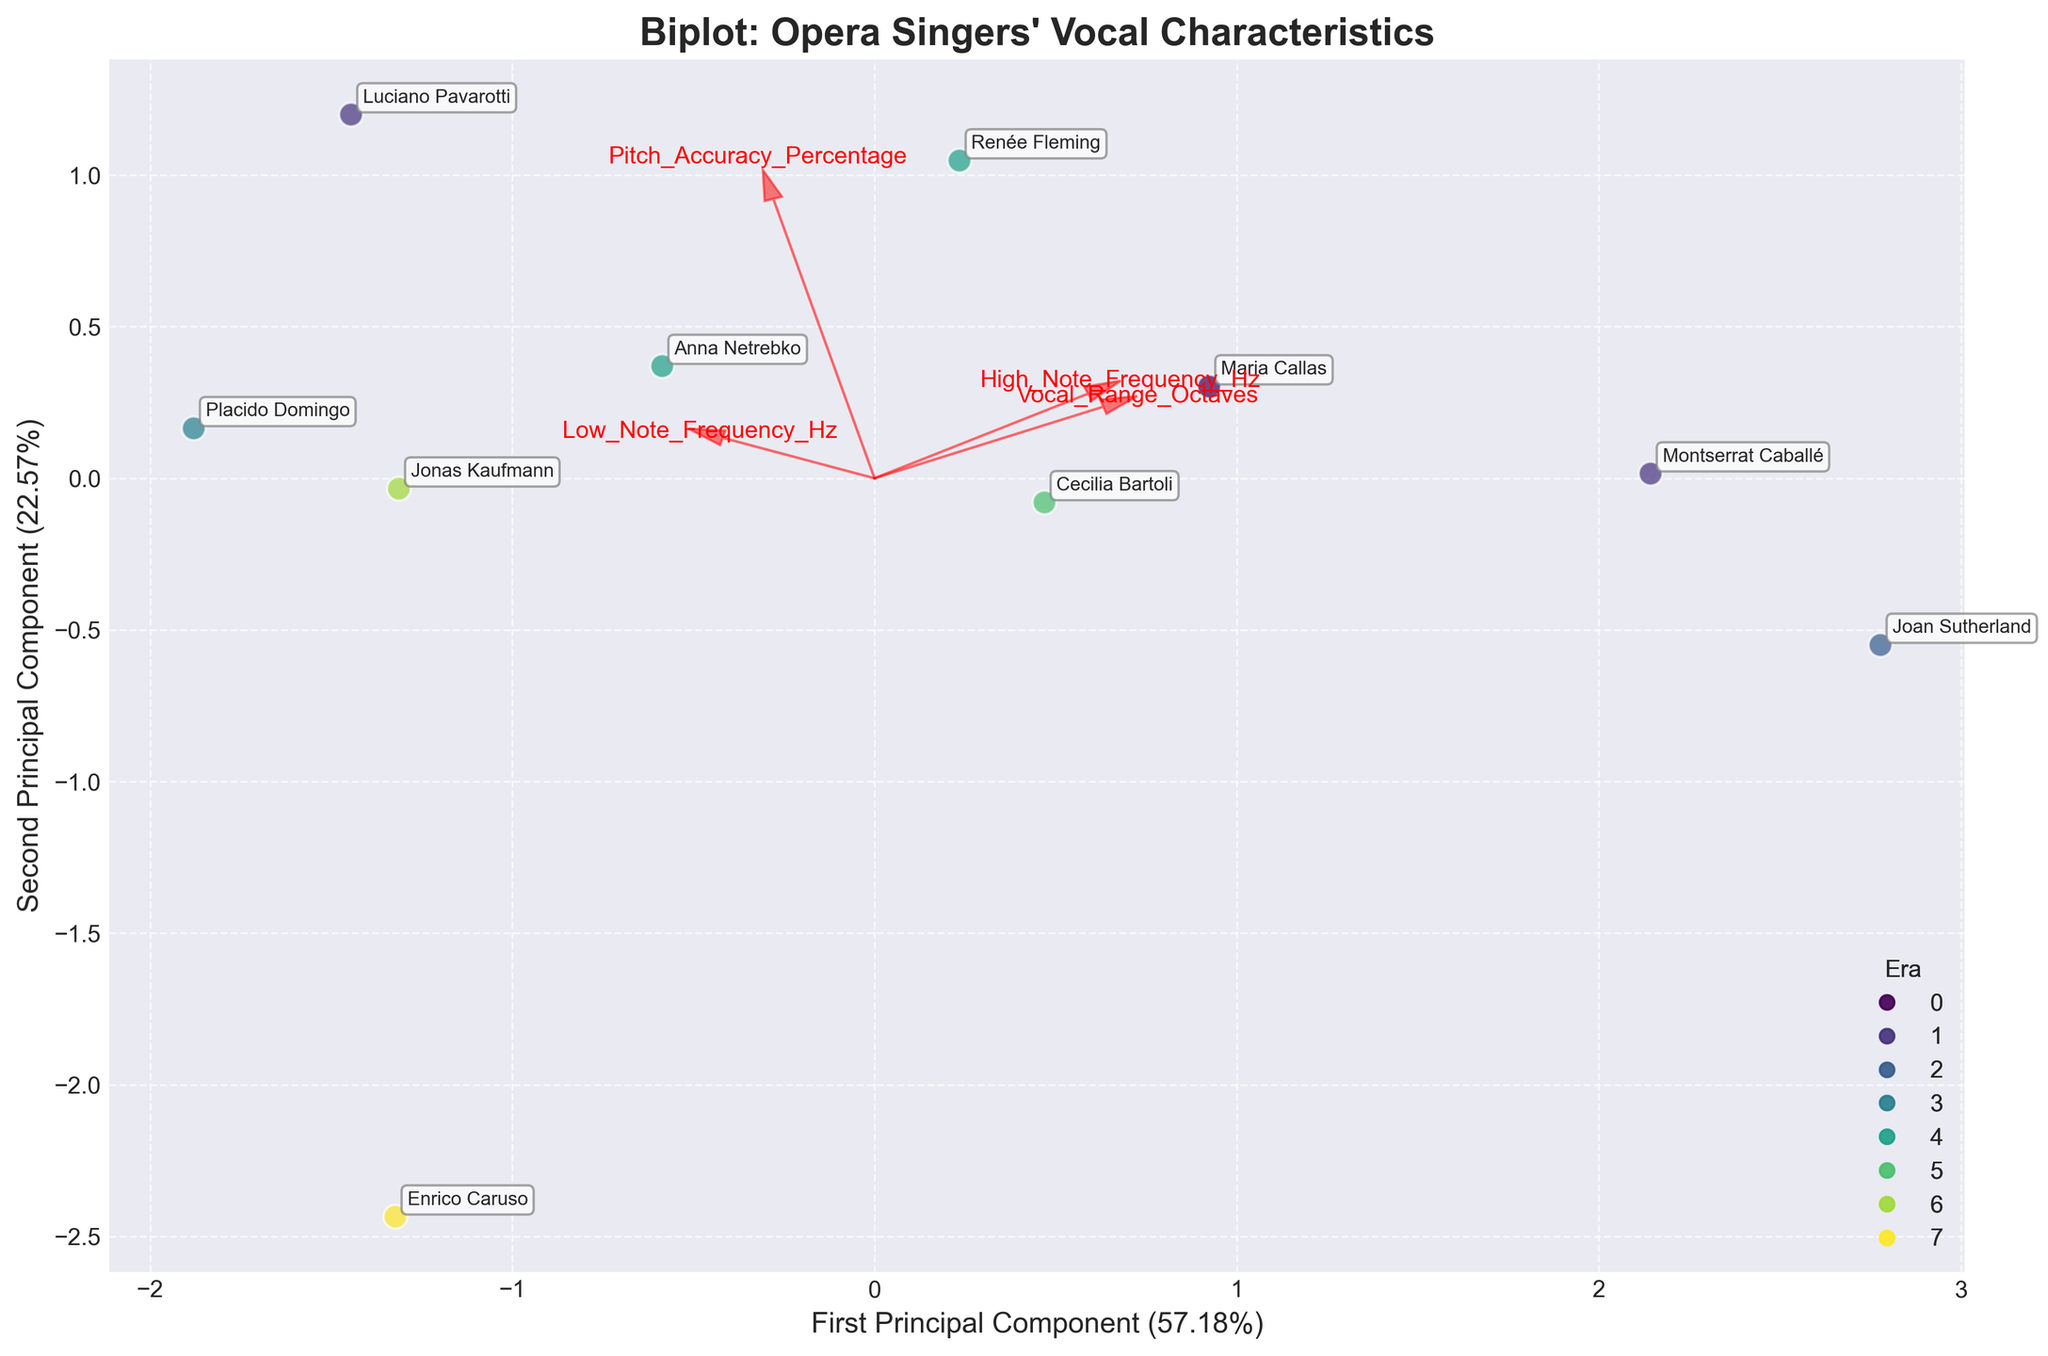What is the title of the plot? The title of the plot is displayed at the top of the figure and reads "Biplot: Opera Singers' Vocal Characteristics". This tells us the main subject of the plot.
Answer: Biplot: Opera Singers' Vocal Characteristics How many principal components are shown in the plot? The plot shows two principal components. This can be determined by the two axes labeled "First Principal Component" and "Second Principal Component".
Answer: Two Which era has the highest number of singers in the plot? By looking at the colors and the legend, we can count the number of points for each era. The era with the highest number of points will be the one with the most singers.
Answer: 2000s Which singer has the highest vocal range in octaves? The singer with the highest vocal range in octaves will be positioned further in the direction of the arrow labeled "Vocal_Range_Octaves". By checking this direction, we find Joan Sutherland.
Answer: Joan Sutherland What are the percentages of variance explained by the first and second principal components? The percentages of variance explained are presented in the axis labels. The first principal component explains 39.8%, and the second explains 27.5%.
Answer: 39.8% and 27.5% Who among the singers has the lowest pitch accuracy percentage? The position of each singer relative to the arrow labeled "Pitch_Accuracy_Percentage" indicates their pitch accuracy. The singer furthest in the opposite direction of this arrow has the lowest accuracy.
Answer: Enrico Caruso Compare the vocal range in octaves between singers from the 1950s and the 2000s. Which group generally has a wider range? By comparing the positions along the "Vocal_Range_Octaves" arrow of singers from the 1950s (Maria Callas) and the 2000s (Renée Fleming, Anna Netrebko), we can see that Maria Callas (1950s) has a higher range in octaves.
Answer: 1950s Identify the singers grouped closely together. What might this indicate about their vocal characteristics? Singers in the plot like Renée Fleming and Anna Netrebko are grouped closely together, indicating their vocal characteristics such as range and accuracy are similar.
Answer: Renée Fleming and Anna Netrebko Which era shows a singer with the highest pitch accuracy and who is it? The arrow labeled "Pitch_Accuracy_Percentage" helps us identify this. Luciano Pavarotti (1970s) is located furthest in the direction of this arrow.
Answer: 1970s, Luciano Pavarotti 